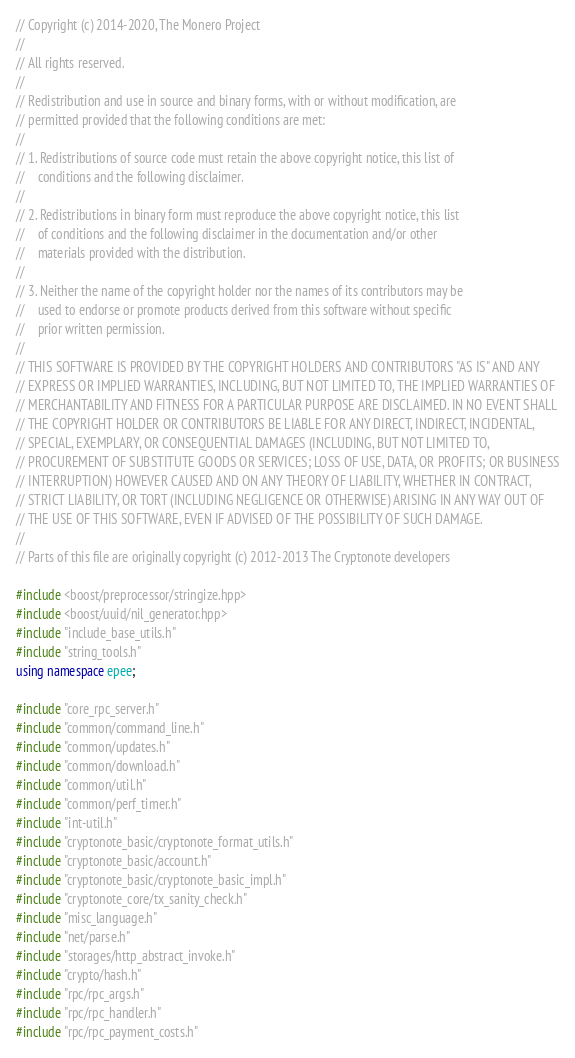<code> <loc_0><loc_0><loc_500><loc_500><_C++_>// Copyright (c) 2014-2020, The Monero Project
//
// All rights reserved.
//
// Redistribution and use in source and binary forms, with or without modification, are
// permitted provided that the following conditions are met:
//
// 1. Redistributions of source code must retain the above copyright notice, this list of
//    conditions and the following disclaimer.
//
// 2. Redistributions in binary form must reproduce the above copyright notice, this list
//    of conditions and the following disclaimer in the documentation and/or other
//    materials provided with the distribution.
//
// 3. Neither the name of the copyright holder nor the names of its contributors may be
//    used to endorse or promote products derived from this software without specific
//    prior written permission.
//
// THIS SOFTWARE IS PROVIDED BY THE COPYRIGHT HOLDERS AND CONTRIBUTORS "AS IS" AND ANY
// EXPRESS OR IMPLIED WARRANTIES, INCLUDING, BUT NOT LIMITED TO, THE IMPLIED WARRANTIES OF
// MERCHANTABILITY AND FITNESS FOR A PARTICULAR PURPOSE ARE DISCLAIMED. IN NO EVENT SHALL
// THE COPYRIGHT HOLDER OR CONTRIBUTORS BE LIABLE FOR ANY DIRECT, INDIRECT, INCIDENTAL,
// SPECIAL, EXEMPLARY, OR CONSEQUENTIAL DAMAGES (INCLUDING, BUT NOT LIMITED TO,
// PROCUREMENT OF SUBSTITUTE GOODS OR SERVICES; LOSS OF USE, DATA, OR PROFITS; OR BUSINESS
// INTERRUPTION) HOWEVER CAUSED AND ON ANY THEORY OF LIABILITY, WHETHER IN CONTRACT,
// STRICT LIABILITY, OR TORT (INCLUDING NEGLIGENCE OR OTHERWISE) ARISING IN ANY WAY OUT OF
// THE USE OF THIS SOFTWARE, EVEN IF ADVISED OF THE POSSIBILITY OF SUCH DAMAGE.
//
// Parts of this file are originally copyright (c) 2012-2013 The Cryptonote developers

#include <boost/preprocessor/stringize.hpp>
#include <boost/uuid/nil_generator.hpp>
#include "include_base_utils.h"
#include "string_tools.h"
using namespace epee;

#include "core_rpc_server.h"
#include "common/command_line.h"
#include "common/updates.h"
#include "common/download.h"
#include "common/util.h"
#include "common/perf_timer.h"
#include "int-util.h"
#include "cryptonote_basic/cryptonote_format_utils.h"
#include "cryptonote_basic/account.h"
#include "cryptonote_basic/cryptonote_basic_impl.h"
#include "cryptonote_core/tx_sanity_check.h"
#include "misc_language.h"
#include "net/parse.h"
#include "storages/http_abstract_invoke.h"
#include "crypto/hash.h"
#include "rpc/rpc_args.h"
#include "rpc/rpc_handler.h"
#include "rpc/rpc_payment_costs.h"</code> 